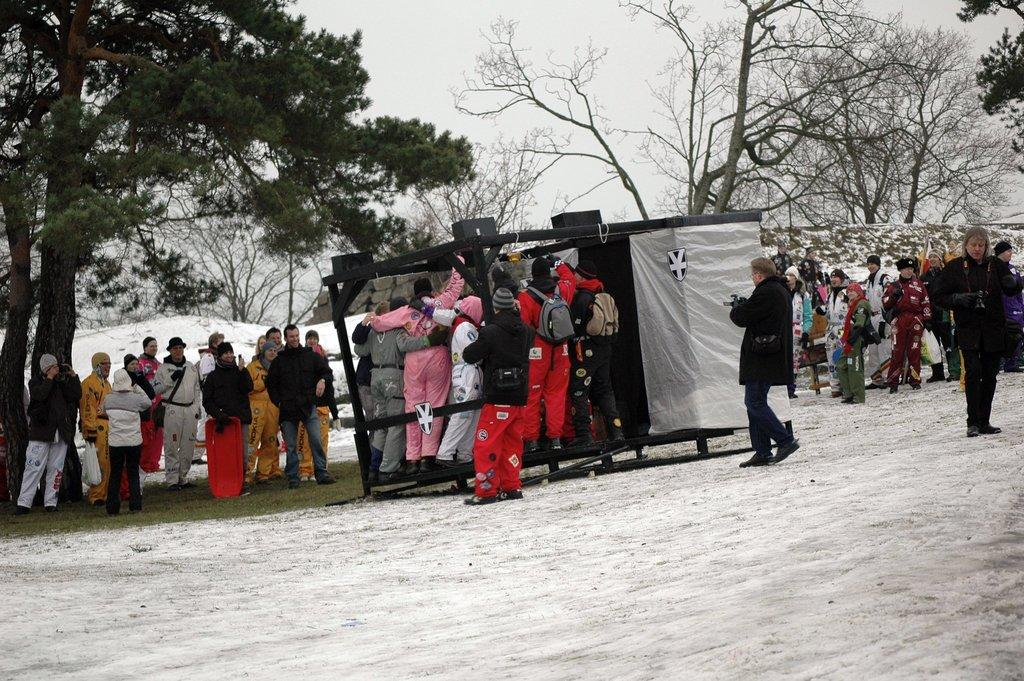What type of vegetation can be seen in the image? There are trees in the image. What are the people in the image wearing? The people are wearing coats and caps. What accessories are some people wearing in the image? Some people are wearing bags. What are some people holding in the image? Some people are holding objects. What type of structure is present in the image? There is a shed in the image. What is the ground made of in the image? There is sand at the bottom of the image. How many snails can be seen crawling on the trees in the image? There are no snails present in the image; it only features trees, people, a shed, and sand. What color is the crayon being used by the person in the image? There is no crayon present in the image; people are holding objects, but no crayons are mentioned. 